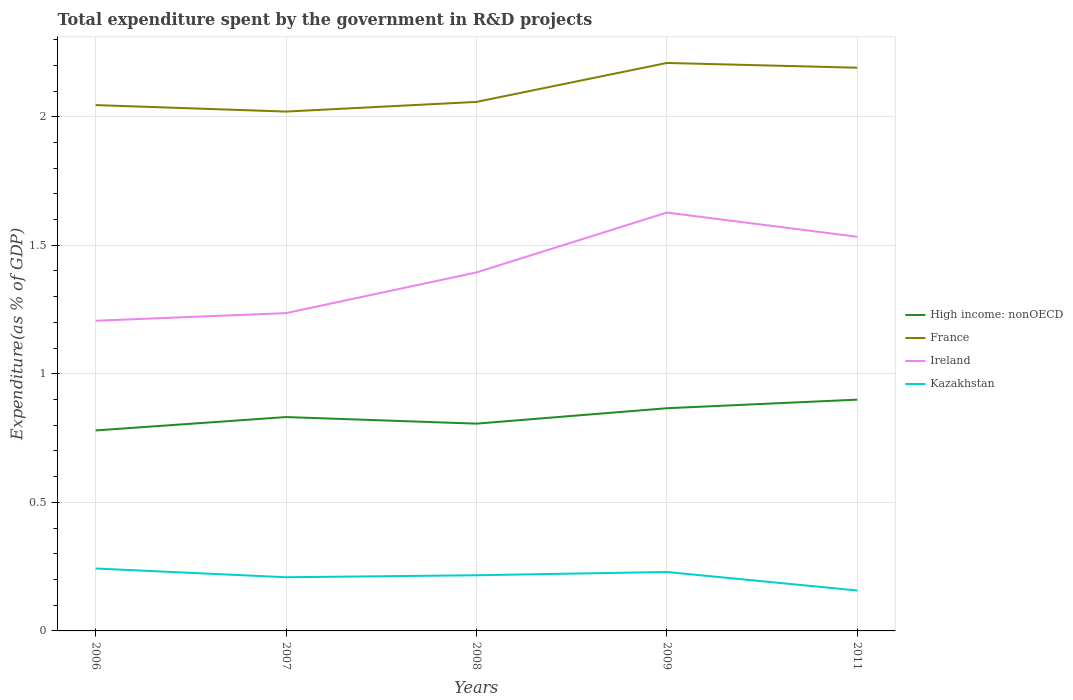How many different coloured lines are there?
Give a very brief answer. 4. Across all years, what is the maximum total expenditure spent by the government in R&D projects in High income: nonOECD?
Ensure brevity in your answer.  0.78. What is the total total expenditure spent by the government in R&D projects in Kazakhstan in the graph?
Make the answer very short. 0.07. What is the difference between the highest and the second highest total expenditure spent by the government in R&D projects in France?
Provide a succinct answer. 0.19. What is the difference between the highest and the lowest total expenditure spent by the government in R&D projects in France?
Offer a terse response. 2. Is the total expenditure spent by the government in R&D projects in France strictly greater than the total expenditure spent by the government in R&D projects in Kazakhstan over the years?
Ensure brevity in your answer.  No. How many lines are there?
Offer a terse response. 4. Are the values on the major ticks of Y-axis written in scientific E-notation?
Give a very brief answer. No. Does the graph contain grids?
Offer a terse response. Yes. Where does the legend appear in the graph?
Provide a succinct answer. Center right. How many legend labels are there?
Ensure brevity in your answer.  4. What is the title of the graph?
Give a very brief answer. Total expenditure spent by the government in R&D projects. Does "United Kingdom" appear as one of the legend labels in the graph?
Provide a short and direct response. No. What is the label or title of the Y-axis?
Keep it short and to the point. Expenditure(as % of GDP). What is the Expenditure(as % of GDP) in High income: nonOECD in 2006?
Provide a short and direct response. 0.78. What is the Expenditure(as % of GDP) in France in 2006?
Give a very brief answer. 2.05. What is the Expenditure(as % of GDP) of Ireland in 2006?
Provide a short and direct response. 1.21. What is the Expenditure(as % of GDP) of Kazakhstan in 2006?
Provide a short and direct response. 0.24. What is the Expenditure(as % of GDP) in High income: nonOECD in 2007?
Offer a very short reply. 0.83. What is the Expenditure(as % of GDP) of France in 2007?
Make the answer very short. 2.02. What is the Expenditure(as % of GDP) in Ireland in 2007?
Offer a very short reply. 1.24. What is the Expenditure(as % of GDP) in Kazakhstan in 2007?
Offer a terse response. 0.21. What is the Expenditure(as % of GDP) of High income: nonOECD in 2008?
Give a very brief answer. 0.81. What is the Expenditure(as % of GDP) of France in 2008?
Provide a short and direct response. 2.06. What is the Expenditure(as % of GDP) of Ireland in 2008?
Ensure brevity in your answer.  1.39. What is the Expenditure(as % of GDP) of Kazakhstan in 2008?
Provide a succinct answer. 0.22. What is the Expenditure(as % of GDP) in High income: nonOECD in 2009?
Offer a terse response. 0.87. What is the Expenditure(as % of GDP) of France in 2009?
Offer a very short reply. 2.21. What is the Expenditure(as % of GDP) of Ireland in 2009?
Give a very brief answer. 1.63. What is the Expenditure(as % of GDP) of Kazakhstan in 2009?
Offer a very short reply. 0.23. What is the Expenditure(as % of GDP) in High income: nonOECD in 2011?
Ensure brevity in your answer.  0.9. What is the Expenditure(as % of GDP) of France in 2011?
Provide a succinct answer. 2.19. What is the Expenditure(as % of GDP) of Ireland in 2011?
Give a very brief answer. 1.53. What is the Expenditure(as % of GDP) in Kazakhstan in 2011?
Ensure brevity in your answer.  0.16. Across all years, what is the maximum Expenditure(as % of GDP) in High income: nonOECD?
Offer a terse response. 0.9. Across all years, what is the maximum Expenditure(as % of GDP) in France?
Offer a very short reply. 2.21. Across all years, what is the maximum Expenditure(as % of GDP) of Ireland?
Keep it short and to the point. 1.63. Across all years, what is the maximum Expenditure(as % of GDP) in Kazakhstan?
Offer a terse response. 0.24. Across all years, what is the minimum Expenditure(as % of GDP) in High income: nonOECD?
Offer a very short reply. 0.78. Across all years, what is the minimum Expenditure(as % of GDP) of France?
Keep it short and to the point. 2.02. Across all years, what is the minimum Expenditure(as % of GDP) in Ireland?
Offer a very short reply. 1.21. Across all years, what is the minimum Expenditure(as % of GDP) of Kazakhstan?
Your answer should be very brief. 0.16. What is the total Expenditure(as % of GDP) in High income: nonOECD in the graph?
Keep it short and to the point. 4.18. What is the total Expenditure(as % of GDP) of France in the graph?
Your answer should be compact. 10.52. What is the total Expenditure(as % of GDP) of Ireland in the graph?
Keep it short and to the point. 7. What is the total Expenditure(as % of GDP) of Kazakhstan in the graph?
Your answer should be very brief. 1.05. What is the difference between the Expenditure(as % of GDP) in High income: nonOECD in 2006 and that in 2007?
Provide a short and direct response. -0.05. What is the difference between the Expenditure(as % of GDP) of France in 2006 and that in 2007?
Offer a terse response. 0.03. What is the difference between the Expenditure(as % of GDP) in Ireland in 2006 and that in 2007?
Make the answer very short. -0.03. What is the difference between the Expenditure(as % of GDP) of Kazakhstan in 2006 and that in 2007?
Your answer should be compact. 0.03. What is the difference between the Expenditure(as % of GDP) of High income: nonOECD in 2006 and that in 2008?
Provide a succinct answer. -0.03. What is the difference between the Expenditure(as % of GDP) in France in 2006 and that in 2008?
Your response must be concise. -0.01. What is the difference between the Expenditure(as % of GDP) in Ireland in 2006 and that in 2008?
Provide a short and direct response. -0.19. What is the difference between the Expenditure(as % of GDP) in Kazakhstan in 2006 and that in 2008?
Offer a terse response. 0.03. What is the difference between the Expenditure(as % of GDP) in High income: nonOECD in 2006 and that in 2009?
Provide a short and direct response. -0.09. What is the difference between the Expenditure(as % of GDP) in France in 2006 and that in 2009?
Provide a succinct answer. -0.16. What is the difference between the Expenditure(as % of GDP) of Ireland in 2006 and that in 2009?
Make the answer very short. -0.42. What is the difference between the Expenditure(as % of GDP) in Kazakhstan in 2006 and that in 2009?
Provide a succinct answer. 0.01. What is the difference between the Expenditure(as % of GDP) in High income: nonOECD in 2006 and that in 2011?
Ensure brevity in your answer.  -0.12. What is the difference between the Expenditure(as % of GDP) of France in 2006 and that in 2011?
Your answer should be very brief. -0.15. What is the difference between the Expenditure(as % of GDP) in Ireland in 2006 and that in 2011?
Offer a very short reply. -0.33. What is the difference between the Expenditure(as % of GDP) in Kazakhstan in 2006 and that in 2011?
Your answer should be very brief. 0.09. What is the difference between the Expenditure(as % of GDP) of High income: nonOECD in 2007 and that in 2008?
Keep it short and to the point. 0.03. What is the difference between the Expenditure(as % of GDP) of France in 2007 and that in 2008?
Your response must be concise. -0.04. What is the difference between the Expenditure(as % of GDP) of Ireland in 2007 and that in 2008?
Provide a succinct answer. -0.16. What is the difference between the Expenditure(as % of GDP) of Kazakhstan in 2007 and that in 2008?
Provide a succinct answer. -0.01. What is the difference between the Expenditure(as % of GDP) of High income: nonOECD in 2007 and that in 2009?
Your response must be concise. -0.03. What is the difference between the Expenditure(as % of GDP) in France in 2007 and that in 2009?
Your response must be concise. -0.19. What is the difference between the Expenditure(as % of GDP) of Ireland in 2007 and that in 2009?
Offer a terse response. -0.39. What is the difference between the Expenditure(as % of GDP) of Kazakhstan in 2007 and that in 2009?
Offer a terse response. -0.02. What is the difference between the Expenditure(as % of GDP) of High income: nonOECD in 2007 and that in 2011?
Your answer should be very brief. -0.07. What is the difference between the Expenditure(as % of GDP) in France in 2007 and that in 2011?
Offer a terse response. -0.17. What is the difference between the Expenditure(as % of GDP) in Ireland in 2007 and that in 2011?
Your response must be concise. -0.3. What is the difference between the Expenditure(as % of GDP) of Kazakhstan in 2007 and that in 2011?
Provide a succinct answer. 0.05. What is the difference between the Expenditure(as % of GDP) of High income: nonOECD in 2008 and that in 2009?
Make the answer very short. -0.06. What is the difference between the Expenditure(as % of GDP) of France in 2008 and that in 2009?
Your answer should be very brief. -0.15. What is the difference between the Expenditure(as % of GDP) in Ireland in 2008 and that in 2009?
Your response must be concise. -0.23. What is the difference between the Expenditure(as % of GDP) of Kazakhstan in 2008 and that in 2009?
Your answer should be very brief. -0.01. What is the difference between the Expenditure(as % of GDP) in High income: nonOECD in 2008 and that in 2011?
Keep it short and to the point. -0.09. What is the difference between the Expenditure(as % of GDP) of France in 2008 and that in 2011?
Provide a succinct answer. -0.13. What is the difference between the Expenditure(as % of GDP) of Ireland in 2008 and that in 2011?
Give a very brief answer. -0.14. What is the difference between the Expenditure(as % of GDP) of Kazakhstan in 2008 and that in 2011?
Keep it short and to the point. 0.06. What is the difference between the Expenditure(as % of GDP) in High income: nonOECD in 2009 and that in 2011?
Provide a succinct answer. -0.03. What is the difference between the Expenditure(as % of GDP) in France in 2009 and that in 2011?
Ensure brevity in your answer.  0.02. What is the difference between the Expenditure(as % of GDP) in Ireland in 2009 and that in 2011?
Your answer should be very brief. 0.09. What is the difference between the Expenditure(as % of GDP) in Kazakhstan in 2009 and that in 2011?
Offer a terse response. 0.07. What is the difference between the Expenditure(as % of GDP) of High income: nonOECD in 2006 and the Expenditure(as % of GDP) of France in 2007?
Offer a terse response. -1.24. What is the difference between the Expenditure(as % of GDP) of High income: nonOECD in 2006 and the Expenditure(as % of GDP) of Ireland in 2007?
Your response must be concise. -0.46. What is the difference between the Expenditure(as % of GDP) in High income: nonOECD in 2006 and the Expenditure(as % of GDP) in Kazakhstan in 2007?
Provide a succinct answer. 0.57. What is the difference between the Expenditure(as % of GDP) of France in 2006 and the Expenditure(as % of GDP) of Ireland in 2007?
Your answer should be compact. 0.81. What is the difference between the Expenditure(as % of GDP) of France in 2006 and the Expenditure(as % of GDP) of Kazakhstan in 2007?
Ensure brevity in your answer.  1.84. What is the difference between the Expenditure(as % of GDP) of High income: nonOECD in 2006 and the Expenditure(as % of GDP) of France in 2008?
Give a very brief answer. -1.28. What is the difference between the Expenditure(as % of GDP) in High income: nonOECD in 2006 and the Expenditure(as % of GDP) in Ireland in 2008?
Ensure brevity in your answer.  -0.61. What is the difference between the Expenditure(as % of GDP) of High income: nonOECD in 2006 and the Expenditure(as % of GDP) of Kazakhstan in 2008?
Keep it short and to the point. 0.56. What is the difference between the Expenditure(as % of GDP) of France in 2006 and the Expenditure(as % of GDP) of Ireland in 2008?
Offer a very short reply. 0.65. What is the difference between the Expenditure(as % of GDP) in France in 2006 and the Expenditure(as % of GDP) in Kazakhstan in 2008?
Provide a short and direct response. 1.83. What is the difference between the Expenditure(as % of GDP) in Ireland in 2006 and the Expenditure(as % of GDP) in Kazakhstan in 2008?
Your answer should be very brief. 0.99. What is the difference between the Expenditure(as % of GDP) in High income: nonOECD in 2006 and the Expenditure(as % of GDP) in France in 2009?
Provide a short and direct response. -1.43. What is the difference between the Expenditure(as % of GDP) in High income: nonOECD in 2006 and the Expenditure(as % of GDP) in Ireland in 2009?
Offer a terse response. -0.85. What is the difference between the Expenditure(as % of GDP) in High income: nonOECD in 2006 and the Expenditure(as % of GDP) in Kazakhstan in 2009?
Your response must be concise. 0.55. What is the difference between the Expenditure(as % of GDP) of France in 2006 and the Expenditure(as % of GDP) of Ireland in 2009?
Give a very brief answer. 0.42. What is the difference between the Expenditure(as % of GDP) in France in 2006 and the Expenditure(as % of GDP) in Kazakhstan in 2009?
Provide a succinct answer. 1.82. What is the difference between the Expenditure(as % of GDP) in Ireland in 2006 and the Expenditure(as % of GDP) in Kazakhstan in 2009?
Make the answer very short. 0.98. What is the difference between the Expenditure(as % of GDP) of High income: nonOECD in 2006 and the Expenditure(as % of GDP) of France in 2011?
Provide a short and direct response. -1.41. What is the difference between the Expenditure(as % of GDP) in High income: nonOECD in 2006 and the Expenditure(as % of GDP) in Ireland in 2011?
Your response must be concise. -0.75. What is the difference between the Expenditure(as % of GDP) in High income: nonOECD in 2006 and the Expenditure(as % of GDP) in Kazakhstan in 2011?
Keep it short and to the point. 0.62. What is the difference between the Expenditure(as % of GDP) in France in 2006 and the Expenditure(as % of GDP) in Ireland in 2011?
Give a very brief answer. 0.51. What is the difference between the Expenditure(as % of GDP) of France in 2006 and the Expenditure(as % of GDP) of Kazakhstan in 2011?
Keep it short and to the point. 1.89. What is the difference between the Expenditure(as % of GDP) of Ireland in 2006 and the Expenditure(as % of GDP) of Kazakhstan in 2011?
Provide a succinct answer. 1.05. What is the difference between the Expenditure(as % of GDP) in High income: nonOECD in 2007 and the Expenditure(as % of GDP) in France in 2008?
Offer a very short reply. -1.23. What is the difference between the Expenditure(as % of GDP) of High income: nonOECD in 2007 and the Expenditure(as % of GDP) of Ireland in 2008?
Your answer should be compact. -0.56. What is the difference between the Expenditure(as % of GDP) in High income: nonOECD in 2007 and the Expenditure(as % of GDP) in Kazakhstan in 2008?
Give a very brief answer. 0.62. What is the difference between the Expenditure(as % of GDP) of France in 2007 and the Expenditure(as % of GDP) of Ireland in 2008?
Give a very brief answer. 0.63. What is the difference between the Expenditure(as % of GDP) in France in 2007 and the Expenditure(as % of GDP) in Kazakhstan in 2008?
Ensure brevity in your answer.  1.8. What is the difference between the Expenditure(as % of GDP) in Ireland in 2007 and the Expenditure(as % of GDP) in Kazakhstan in 2008?
Your answer should be very brief. 1.02. What is the difference between the Expenditure(as % of GDP) in High income: nonOECD in 2007 and the Expenditure(as % of GDP) in France in 2009?
Provide a succinct answer. -1.38. What is the difference between the Expenditure(as % of GDP) in High income: nonOECD in 2007 and the Expenditure(as % of GDP) in Ireland in 2009?
Keep it short and to the point. -0.8. What is the difference between the Expenditure(as % of GDP) of High income: nonOECD in 2007 and the Expenditure(as % of GDP) of Kazakhstan in 2009?
Offer a terse response. 0.6. What is the difference between the Expenditure(as % of GDP) in France in 2007 and the Expenditure(as % of GDP) in Ireland in 2009?
Your response must be concise. 0.39. What is the difference between the Expenditure(as % of GDP) of France in 2007 and the Expenditure(as % of GDP) of Kazakhstan in 2009?
Provide a succinct answer. 1.79. What is the difference between the Expenditure(as % of GDP) of Ireland in 2007 and the Expenditure(as % of GDP) of Kazakhstan in 2009?
Offer a terse response. 1.01. What is the difference between the Expenditure(as % of GDP) of High income: nonOECD in 2007 and the Expenditure(as % of GDP) of France in 2011?
Give a very brief answer. -1.36. What is the difference between the Expenditure(as % of GDP) of High income: nonOECD in 2007 and the Expenditure(as % of GDP) of Ireland in 2011?
Make the answer very short. -0.7. What is the difference between the Expenditure(as % of GDP) in High income: nonOECD in 2007 and the Expenditure(as % of GDP) in Kazakhstan in 2011?
Give a very brief answer. 0.67. What is the difference between the Expenditure(as % of GDP) in France in 2007 and the Expenditure(as % of GDP) in Ireland in 2011?
Ensure brevity in your answer.  0.49. What is the difference between the Expenditure(as % of GDP) in France in 2007 and the Expenditure(as % of GDP) in Kazakhstan in 2011?
Keep it short and to the point. 1.86. What is the difference between the Expenditure(as % of GDP) of Ireland in 2007 and the Expenditure(as % of GDP) of Kazakhstan in 2011?
Your answer should be very brief. 1.08. What is the difference between the Expenditure(as % of GDP) in High income: nonOECD in 2008 and the Expenditure(as % of GDP) in France in 2009?
Your response must be concise. -1.4. What is the difference between the Expenditure(as % of GDP) of High income: nonOECD in 2008 and the Expenditure(as % of GDP) of Ireland in 2009?
Your answer should be compact. -0.82. What is the difference between the Expenditure(as % of GDP) in High income: nonOECD in 2008 and the Expenditure(as % of GDP) in Kazakhstan in 2009?
Provide a succinct answer. 0.58. What is the difference between the Expenditure(as % of GDP) in France in 2008 and the Expenditure(as % of GDP) in Ireland in 2009?
Your answer should be compact. 0.43. What is the difference between the Expenditure(as % of GDP) of France in 2008 and the Expenditure(as % of GDP) of Kazakhstan in 2009?
Make the answer very short. 1.83. What is the difference between the Expenditure(as % of GDP) in Ireland in 2008 and the Expenditure(as % of GDP) in Kazakhstan in 2009?
Provide a succinct answer. 1.17. What is the difference between the Expenditure(as % of GDP) of High income: nonOECD in 2008 and the Expenditure(as % of GDP) of France in 2011?
Ensure brevity in your answer.  -1.38. What is the difference between the Expenditure(as % of GDP) of High income: nonOECD in 2008 and the Expenditure(as % of GDP) of Ireland in 2011?
Offer a terse response. -0.73. What is the difference between the Expenditure(as % of GDP) in High income: nonOECD in 2008 and the Expenditure(as % of GDP) in Kazakhstan in 2011?
Your response must be concise. 0.65. What is the difference between the Expenditure(as % of GDP) of France in 2008 and the Expenditure(as % of GDP) of Ireland in 2011?
Offer a terse response. 0.52. What is the difference between the Expenditure(as % of GDP) in France in 2008 and the Expenditure(as % of GDP) in Kazakhstan in 2011?
Keep it short and to the point. 1.9. What is the difference between the Expenditure(as % of GDP) in Ireland in 2008 and the Expenditure(as % of GDP) in Kazakhstan in 2011?
Your answer should be very brief. 1.24. What is the difference between the Expenditure(as % of GDP) in High income: nonOECD in 2009 and the Expenditure(as % of GDP) in France in 2011?
Your response must be concise. -1.32. What is the difference between the Expenditure(as % of GDP) in High income: nonOECD in 2009 and the Expenditure(as % of GDP) in Ireland in 2011?
Keep it short and to the point. -0.67. What is the difference between the Expenditure(as % of GDP) of High income: nonOECD in 2009 and the Expenditure(as % of GDP) of Kazakhstan in 2011?
Your answer should be compact. 0.71. What is the difference between the Expenditure(as % of GDP) in France in 2009 and the Expenditure(as % of GDP) in Ireland in 2011?
Offer a very short reply. 0.68. What is the difference between the Expenditure(as % of GDP) of France in 2009 and the Expenditure(as % of GDP) of Kazakhstan in 2011?
Offer a very short reply. 2.05. What is the difference between the Expenditure(as % of GDP) of Ireland in 2009 and the Expenditure(as % of GDP) of Kazakhstan in 2011?
Keep it short and to the point. 1.47. What is the average Expenditure(as % of GDP) in High income: nonOECD per year?
Your answer should be compact. 0.84. What is the average Expenditure(as % of GDP) in France per year?
Make the answer very short. 2.1. What is the average Expenditure(as % of GDP) of Ireland per year?
Your answer should be compact. 1.4. What is the average Expenditure(as % of GDP) of Kazakhstan per year?
Provide a succinct answer. 0.21. In the year 2006, what is the difference between the Expenditure(as % of GDP) in High income: nonOECD and Expenditure(as % of GDP) in France?
Keep it short and to the point. -1.27. In the year 2006, what is the difference between the Expenditure(as % of GDP) of High income: nonOECD and Expenditure(as % of GDP) of Ireland?
Give a very brief answer. -0.43. In the year 2006, what is the difference between the Expenditure(as % of GDP) of High income: nonOECD and Expenditure(as % of GDP) of Kazakhstan?
Offer a terse response. 0.54. In the year 2006, what is the difference between the Expenditure(as % of GDP) of France and Expenditure(as % of GDP) of Ireland?
Provide a succinct answer. 0.84. In the year 2006, what is the difference between the Expenditure(as % of GDP) of France and Expenditure(as % of GDP) of Kazakhstan?
Keep it short and to the point. 1.8. In the year 2006, what is the difference between the Expenditure(as % of GDP) in Ireland and Expenditure(as % of GDP) in Kazakhstan?
Offer a very short reply. 0.96. In the year 2007, what is the difference between the Expenditure(as % of GDP) in High income: nonOECD and Expenditure(as % of GDP) in France?
Provide a succinct answer. -1.19. In the year 2007, what is the difference between the Expenditure(as % of GDP) of High income: nonOECD and Expenditure(as % of GDP) of Ireland?
Make the answer very short. -0.4. In the year 2007, what is the difference between the Expenditure(as % of GDP) of High income: nonOECD and Expenditure(as % of GDP) of Kazakhstan?
Offer a terse response. 0.62. In the year 2007, what is the difference between the Expenditure(as % of GDP) in France and Expenditure(as % of GDP) in Ireland?
Your answer should be compact. 0.78. In the year 2007, what is the difference between the Expenditure(as % of GDP) of France and Expenditure(as % of GDP) of Kazakhstan?
Give a very brief answer. 1.81. In the year 2007, what is the difference between the Expenditure(as % of GDP) of Ireland and Expenditure(as % of GDP) of Kazakhstan?
Your answer should be very brief. 1.03. In the year 2008, what is the difference between the Expenditure(as % of GDP) of High income: nonOECD and Expenditure(as % of GDP) of France?
Provide a succinct answer. -1.25. In the year 2008, what is the difference between the Expenditure(as % of GDP) of High income: nonOECD and Expenditure(as % of GDP) of Ireland?
Keep it short and to the point. -0.59. In the year 2008, what is the difference between the Expenditure(as % of GDP) of High income: nonOECD and Expenditure(as % of GDP) of Kazakhstan?
Provide a short and direct response. 0.59. In the year 2008, what is the difference between the Expenditure(as % of GDP) of France and Expenditure(as % of GDP) of Ireland?
Give a very brief answer. 0.66. In the year 2008, what is the difference between the Expenditure(as % of GDP) of France and Expenditure(as % of GDP) of Kazakhstan?
Provide a succinct answer. 1.84. In the year 2008, what is the difference between the Expenditure(as % of GDP) of Ireland and Expenditure(as % of GDP) of Kazakhstan?
Offer a terse response. 1.18. In the year 2009, what is the difference between the Expenditure(as % of GDP) in High income: nonOECD and Expenditure(as % of GDP) in France?
Provide a succinct answer. -1.34. In the year 2009, what is the difference between the Expenditure(as % of GDP) of High income: nonOECD and Expenditure(as % of GDP) of Ireland?
Make the answer very short. -0.76. In the year 2009, what is the difference between the Expenditure(as % of GDP) in High income: nonOECD and Expenditure(as % of GDP) in Kazakhstan?
Give a very brief answer. 0.64. In the year 2009, what is the difference between the Expenditure(as % of GDP) of France and Expenditure(as % of GDP) of Ireland?
Keep it short and to the point. 0.58. In the year 2009, what is the difference between the Expenditure(as % of GDP) of France and Expenditure(as % of GDP) of Kazakhstan?
Provide a succinct answer. 1.98. In the year 2009, what is the difference between the Expenditure(as % of GDP) of Ireland and Expenditure(as % of GDP) of Kazakhstan?
Offer a very short reply. 1.4. In the year 2011, what is the difference between the Expenditure(as % of GDP) in High income: nonOECD and Expenditure(as % of GDP) in France?
Your answer should be very brief. -1.29. In the year 2011, what is the difference between the Expenditure(as % of GDP) of High income: nonOECD and Expenditure(as % of GDP) of Ireland?
Ensure brevity in your answer.  -0.63. In the year 2011, what is the difference between the Expenditure(as % of GDP) in High income: nonOECD and Expenditure(as % of GDP) in Kazakhstan?
Offer a very short reply. 0.74. In the year 2011, what is the difference between the Expenditure(as % of GDP) in France and Expenditure(as % of GDP) in Ireland?
Provide a succinct answer. 0.66. In the year 2011, what is the difference between the Expenditure(as % of GDP) of France and Expenditure(as % of GDP) of Kazakhstan?
Offer a terse response. 2.03. In the year 2011, what is the difference between the Expenditure(as % of GDP) of Ireland and Expenditure(as % of GDP) of Kazakhstan?
Your answer should be compact. 1.38. What is the ratio of the Expenditure(as % of GDP) in High income: nonOECD in 2006 to that in 2007?
Make the answer very short. 0.94. What is the ratio of the Expenditure(as % of GDP) of France in 2006 to that in 2007?
Offer a very short reply. 1.01. What is the ratio of the Expenditure(as % of GDP) of Kazakhstan in 2006 to that in 2007?
Ensure brevity in your answer.  1.16. What is the ratio of the Expenditure(as % of GDP) in High income: nonOECD in 2006 to that in 2008?
Ensure brevity in your answer.  0.97. What is the ratio of the Expenditure(as % of GDP) of Ireland in 2006 to that in 2008?
Make the answer very short. 0.87. What is the ratio of the Expenditure(as % of GDP) of Kazakhstan in 2006 to that in 2008?
Your response must be concise. 1.12. What is the ratio of the Expenditure(as % of GDP) of High income: nonOECD in 2006 to that in 2009?
Ensure brevity in your answer.  0.9. What is the ratio of the Expenditure(as % of GDP) of France in 2006 to that in 2009?
Offer a very short reply. 0.93. What is the ratio of the Expenditure(as % of GDP) in Ireland in 2006 to that in 2009?
Make the answer very short. 0.74. What is the ratio of the Expenditure(as % of GDP) in Kazakhstan in 2006 to that in 2009?
Make the answer very short. 1.06. What is the ratio of the Expenditure(as % of GDP) in High income: nonOECD in 2006 to that in 2011?
Your answer should be compact. 0.87. What is the ratio of the Expenditure(as % of GDP) in France in 2006 to that in 2011?
Offer a very short reply. 0.93. What is the ratio of the Expenditure(as % of GDP) of Ireland in 2006 to that in 2011?
Make the answer very short. 0.79. What is the ratio of the Expenditure(as % of GDP) of Kazakhstan in 2006 to that in 2011?
Keep it short and to the point. 1.54. What is the ratio of the Expenditure(as % of GDP) of High income: nonOECD in 2007 to that in 2008?
Make the answer very short. 1.03. What is the ratio of the Expenditure(as % of GDP) of France in 2007 to that in 2008?
Ensure brevity in your answer.  0.98. What is the ratio of the Expenditure(as % of GDP) in Ireland in 2007 to that in 2008?
Your response must be concise. 0.89. What is the ratio of the Expenditure(as % of GDP) of Kazakhstan in 2007 to that in 2008?
Your answer should be compact. 0.96. What is the ratio of the Expenditure(as % of GDP) of High income: nonOECD in 2007 to that in 2009?
Your answer should be compact. 0.96. What is the ratio of the Expenditure(as % of GDP) in France in 2007 to that in 2009?
Your answer should be compact. 0.91. What is the ratio of the Expenditure(as % of GDP) in Ireland in 2007 to that in 2009?
Provide a succinct answer. 0.76. What is the ratio of the Expenditure(as % of GDP) of Kazakhstan in 2007 to that in 2009?
Provide a succinct answer. 0.91. What is the ratio of the Expenditure(as % of GDP) in High income: nonOECD in 2007 to that in 2011?
Provide a short and direct response. 0.92. What is the ratio of the Expenditure(as % of GDP) in France in 2007 to that in 2011?
Give a very brief answer. 0.92. What is the ratio of the Expenditure(as % of GDP) of Ireland in 2007 to that in 2011?
Offer a very short reply. 0.81. What is the ratio of the Expenditure(as % of GDP) of Kazakhstan in 2007 to that in 2011?
Keep it short and to the point. 1.33. What is the ratio of the Expenditure(as % of GDP) in High income: nonOECD in 2008 to that in 2009?
Make the answer very short. 0.93. What is the ratio of the Expenditure(as % of GDP) in France in 2008 to that in 2009?
Your answer should be compact. 0.93. What is the ratio of the Expenditure(as % of GDP) of Ireland in 2008 to that in 2009?
Offer a very short reply. 0.86. What is the ratio of the Expenditure(as % of GDP) in Kazakhstan in 2008 to that in 2009?
Offer a terse response. 0.94. What is the ratio of the Expenditure(as % of GDP) of High income: nonOECD in 2008 to that in 2011?
Provide a short and direct response. 0.9. What is the ratio of the Expenditure(as % of GDP) in France in 2008 to that in 2011?
Provide a succinct answer. 0.94. What is the ratio of the Expenditure(as % of GDP) of Ireland in 2008 to that in 2011?
Make the answer very short. 0.91. What is the ratio of the Expenditure(as % of GDP) in Kazakhstan in 2008 to that in 2011?
Make the answer very short. 1.38. What is the ratio of the Expenditure(as % of GDP) in High income: nonOECD in 2009 to that in 2011?
Give a very brief answer. 0.96. What is the ratio of the Expenditure(as % of GDP) in France in 2009 to that in 2011?
Offer a very short reply. 1.01. What is the ratio of the Expenditure(as % of GDP) of Ireland in 2009 to that in 2011?
Offer a very short reply. 1.06. What is the ratio of the Expenditure(as % of GDP) of Kazakhstan in 2009 to that in 2011?
Keep it short and to the point. 1.46. What is the difference between the highest and the second highest Expenditure(as % of GDP) in High income: nonOECD?
Your response must be concise. 0.03. What is the difference between the highest and the second highest Expenditure(as % of GDP) in France?
Your response must be concise. 0.02. What is the difference between the highest and the second highest Expenditure(as % of GDP) in Ireland?
Provide a short and direct response. 0.09. What is the difference between the highest and the second highest Expenditure(as % of GDP) in Kazakhstan?
Keep it short and to the point. 0.01. What is the difference between the highest and the lowest Expenditure(as % of GDP) of High income: nonOECD?
Your answer should be compact. 0.12. What is the difference between the highest and the lowest Expenditure(as % of GDP) of France?
Your answer should be very brief. 0.19. What is the difference between the highest and the lowest Expenditure(as % of GDP) of Ireland?
Your answer should be compact. 0.42. What is the difference between the highest and the lowest Expenditure(as % of GDP) in Kazakhstan?
Ensure brevity in your answer.  0.09. 